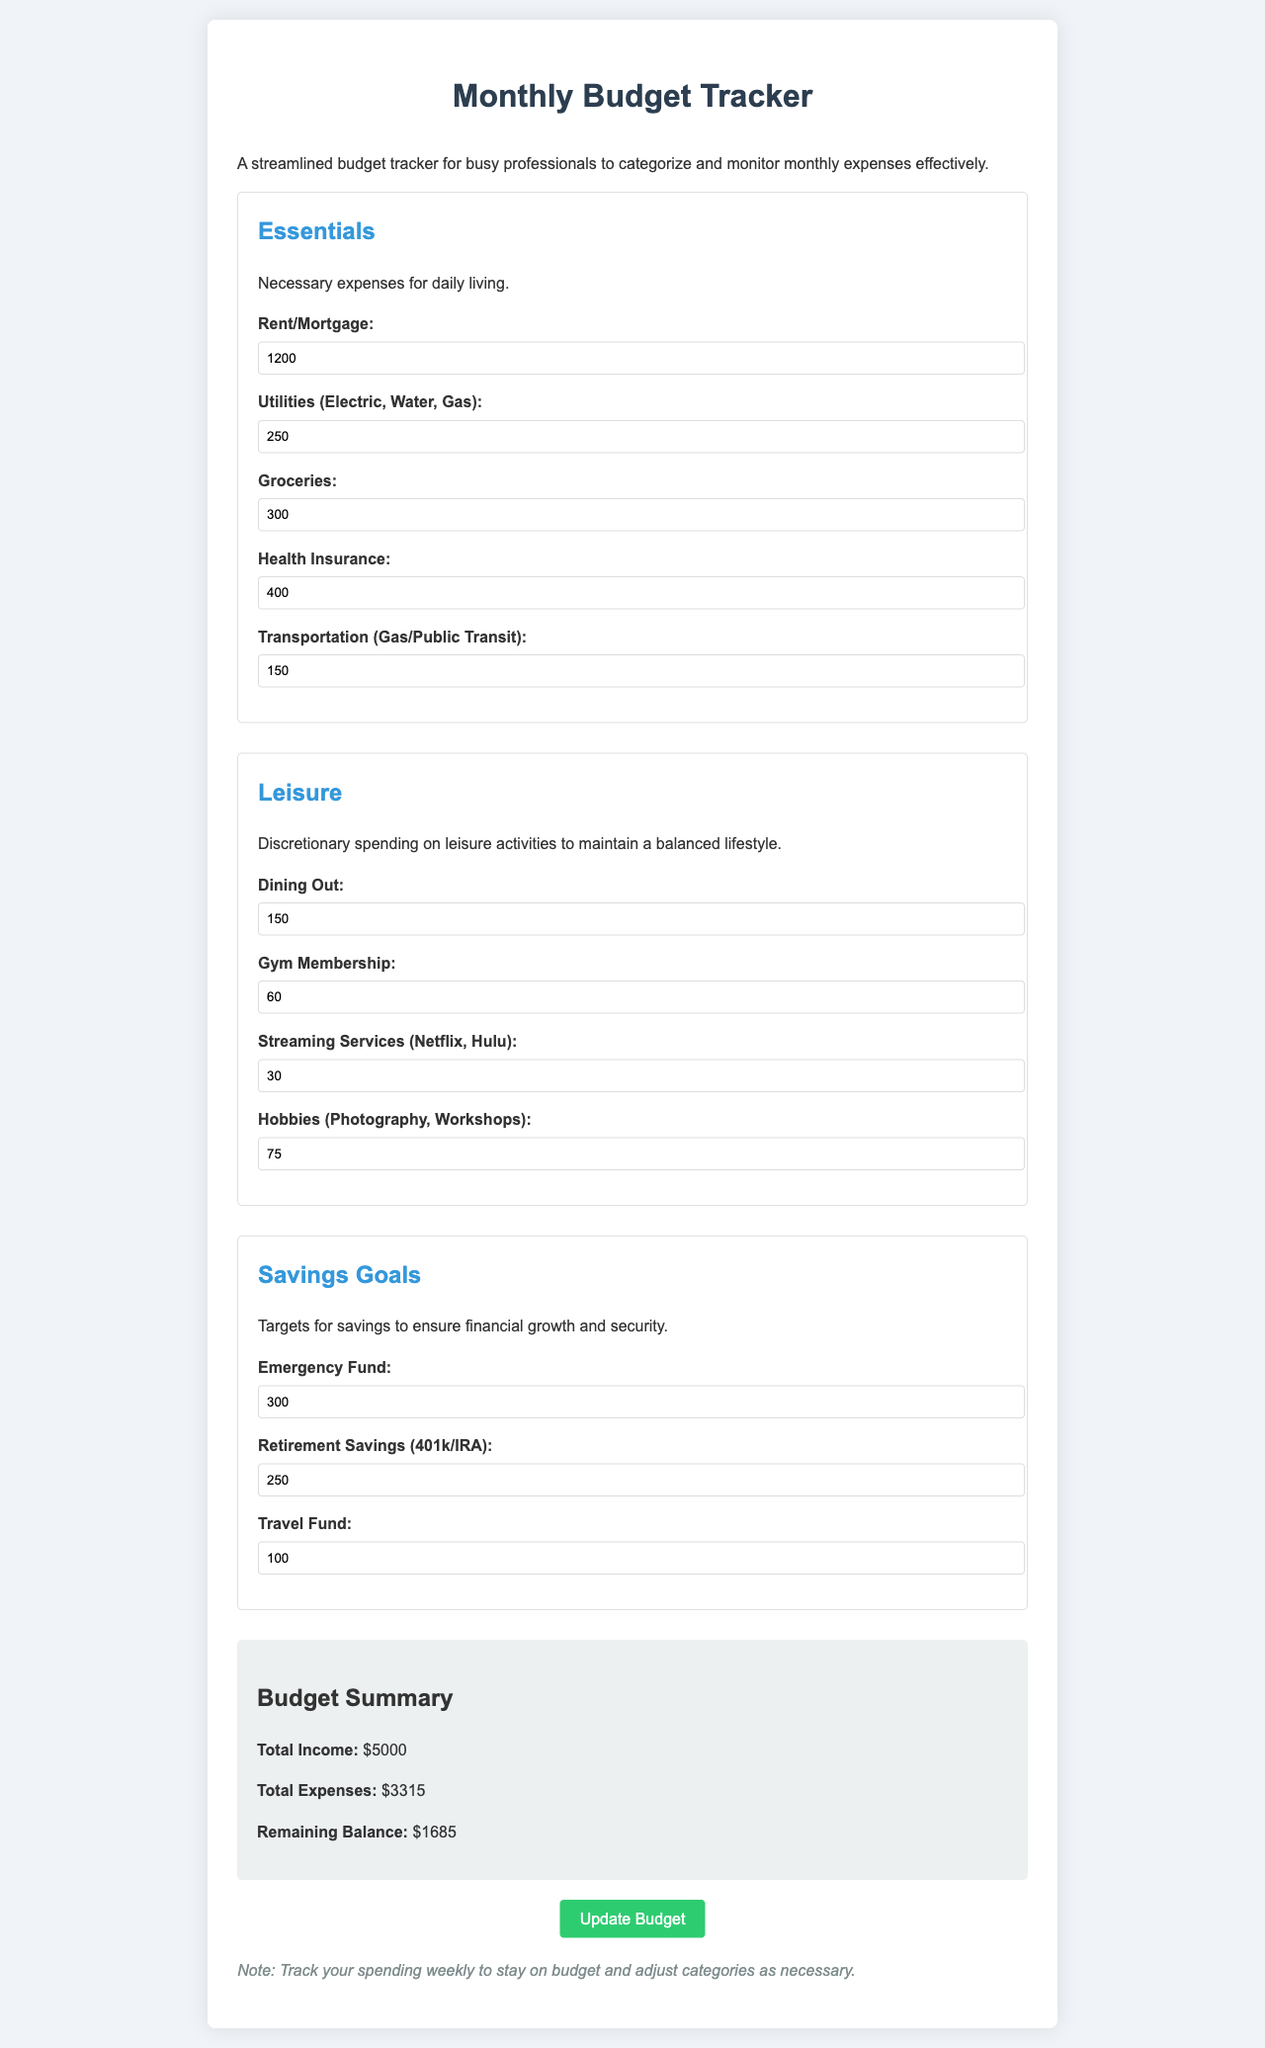What is the total income? The total income is explicitly stated in the document as $5000.
Answer: $5000 What is the total expenses amount? The document specifies the total expenses, summing up all categories, which equals $3315.
Answer: $3315 How much is allocated for groceries? The budget category for groceries lists the expense as $300.
Answer: $300 What is the amount set aside for the emergency fund? The savings goal for the emergency fund is listed as $300 in the document.
Answer: $300 What is the leisure expense for dining out? The document shows that the expense for dining out is $150.
Answer: $150 How much is remaining after all expenses are deducted? The remaining balance is calculated as total income minus total expenses, which is $1685.
Answer: $1685 What is the monthly expense for health insurance? The document states that health insurance costs $400 per month.
Answer: $400 How much is assigned to retirement savings? The allocation for retirement savings, either 401k or IRA, is $250.
Answer: $250 What is the total number of categories listed? The document outlines three main categories: Essentials, Leisure, and Savings Goals.
Answer: 3 